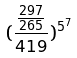Convert formula to latex. <formula><loc_0><loc_0><loc_500><loc_500>( \frac { \frac { 2 9 7 } { 2 6 5 } } { 4 1 9 } ) ^ { 5 ^ { 7 } }</formula> 